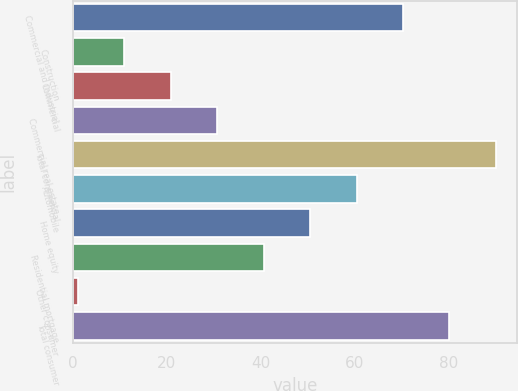Convert chart. <chart><loc_0><loc_0><loc_500><loc_500><bar_chart><fcel>Commercial and industrial<fcel>Construction<fcel>Commercial<fcel>Commercial real estate<fcel>Total commercial<fcel>Automobile<fcel>Home equity<fcel>Residential mortgage<fcel>Other consumer<fcel>Total consumer<nl><fcel>70.3<fcel>10.9<fcel>20.8<fcel>30.7<fcel>90.1<fcel>60.4<fcel>50.5<fcel>40.6<fcel>1<fcel>80.2<nl></chart> 